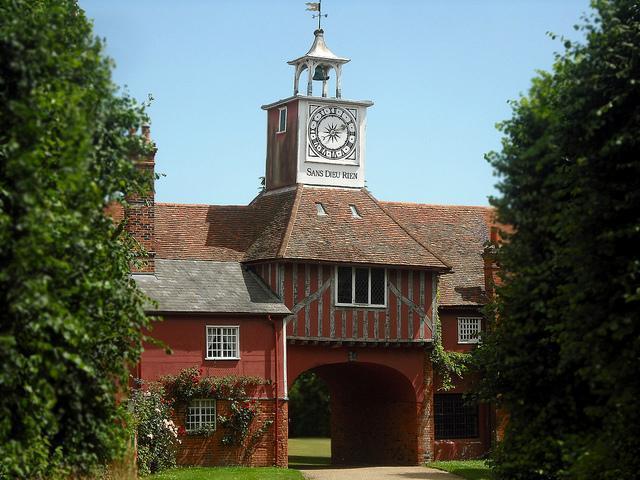How many bells are there?
Give a very brief answer. 1. How many clock faces does this building have?
Give a very brief answer. 1. How many flags are by the building's entrance?
Give a very brief answer. 0. 